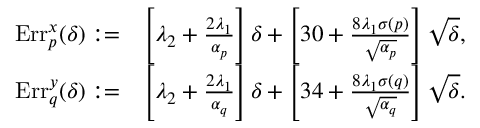Convert formula to latex. <formula><loc_0><loc_0><loc_500><loc_500>\begin{array} { r l } { E r r _ { p } ^ { x } ( \delta ) \colon = } & { \left [ \lambda _ { 2 } + \frac { 2 \lambda _ { 1 } } { \alpha _ { p } } \right ] \delta + \left [ 3 0 + \frac { 8 \lambda _ { 1 } \sigma ( p ) } { \sqrt { \alpha _ { p } } } \right ] \sqrt { \delta } , } \\ { E r r _ { q } ^ { y } ( \delta ) \colon = } & { \left [ \lambda _ { 2 } + \frac { 2 \lambda _ { 1 } } { \alpha _ { q } } \right ] \delta + \left [ 3 4 + \frac { 8 \lambda _ { 1 } \sigma ( q ) } { \sqrt { \alpha _ { q } } } \right ] \sqrt { \delta } . } \end{array}</formula> 